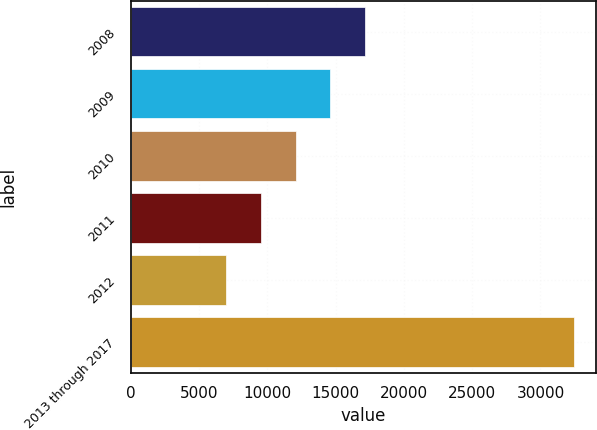Convert chart. <chart><loc_0><loc_0><loc_500><loc_500><bar_chart><fcel>2008<fcel>2009<fcel>2010<fcel>2011<fcel>2012<fcel>2013 through 2017<nl><fcel>17174<fcel>14629<fcel>12084<fcel>9539<fcel>6994<fcel>32444<nl></chart> 